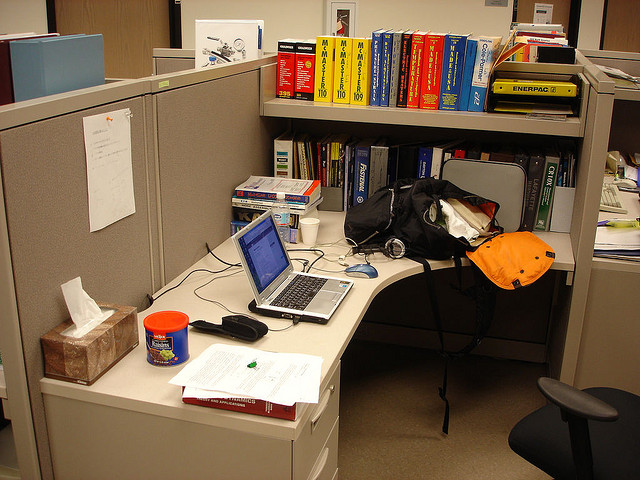Extract all visible text content from this image. McMASTER McMASTER McMASTER BNCRPAC RIOX 110 